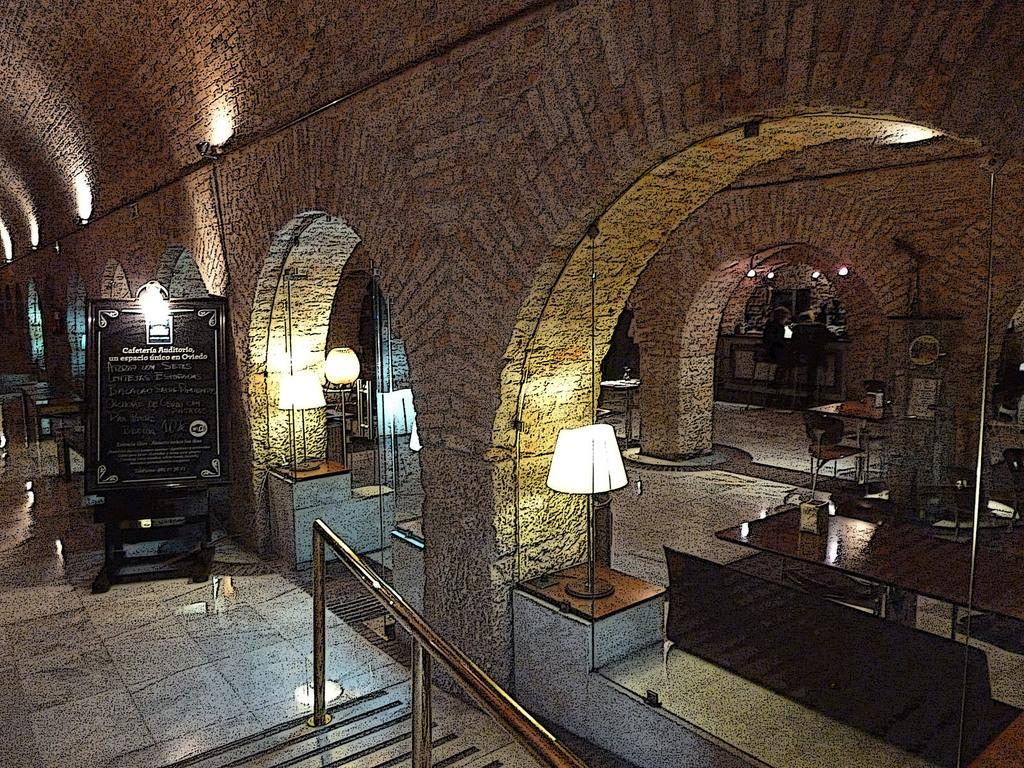What type of furniture is present in the image? There are tables and chairs in the image. What objects provide lighting in the image? There are lamps in the image. What can be seen on the left side of the image? There is a wooden board with matter on it on the left side of the image. What type of home decorations can be seen at the party in the image? There is no mention of a party or home decorations in the image; it features lamps, tables, chairs, and a wooden board with matter on it. How many people are on the trip in the image? There is no trip or people present in the image; it only shows lamps, tables, chairs, and a wooden board with matter on it. 